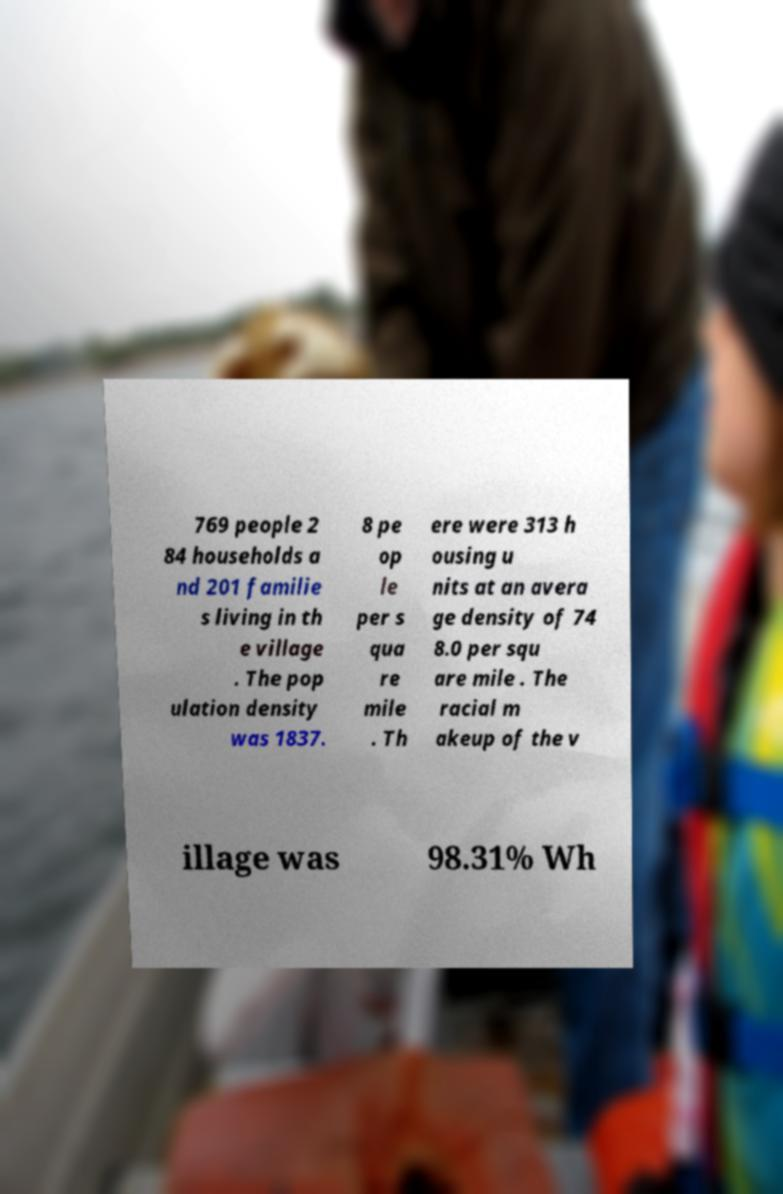Can you accurately transcribe the text from the provided image for me? 769 people 2 84 households a nd 201 familie s living in th e village . The pop ulation density was 1837. 8 pe op le per s qua re mile . Th ere were 313 h ousing u nits at an avera ge density of 74 8.0 per squ are mile . The racial m akeup of the v illage was 98.31% Wh 